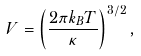Convert formula to latex. <formula><loc_0><loc_0><loc_500><loc_500>V = \left ( \frac { 2 \pi k _ { B } T } { \kappa } \right ) ^ { 3 / 2 } ,</formula> 